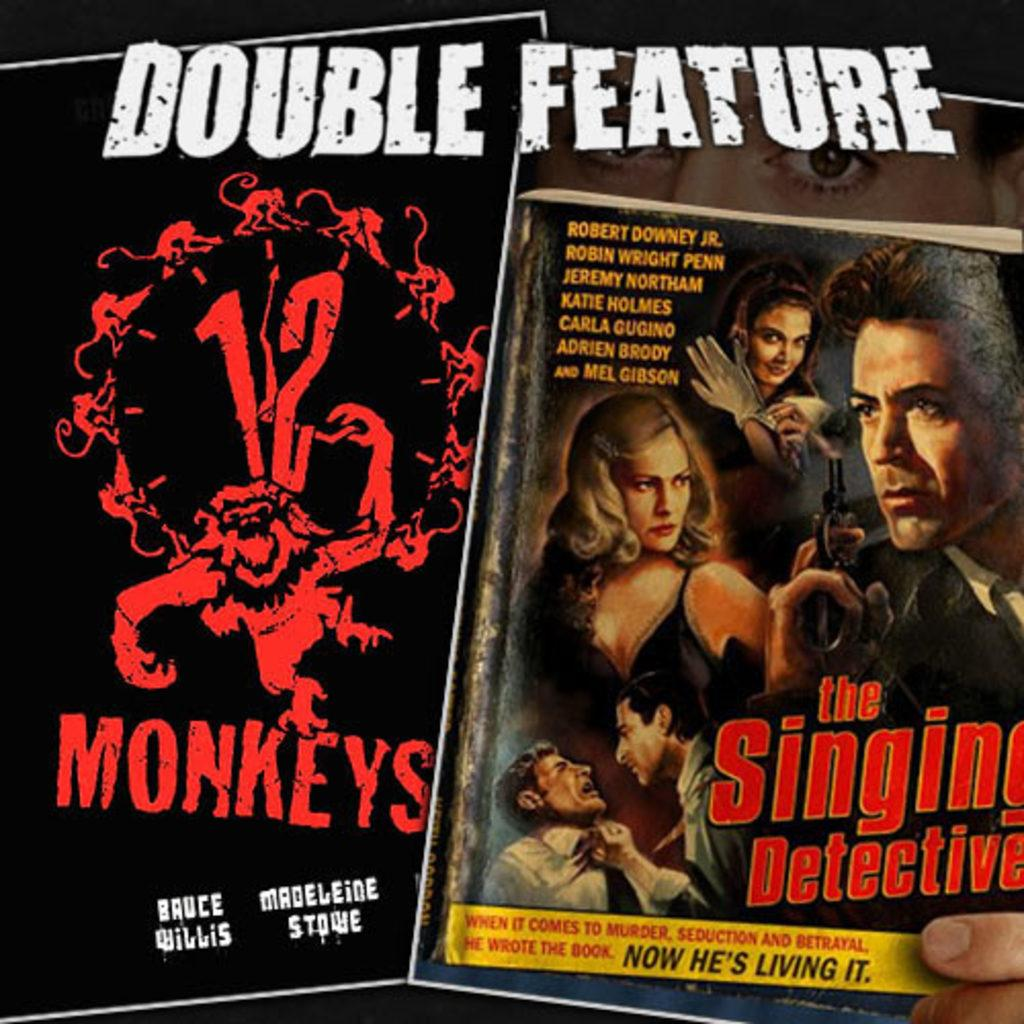<image>
Share a concise interpretation of the image provided. A double feature of the movies 12 Monkeys and The Singing Detective are being advertised. 